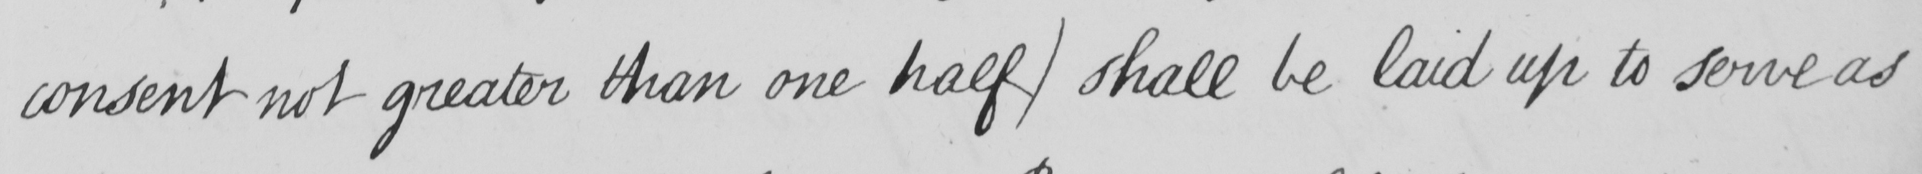Please provide the text content of this handwritten line. consent not greater than one half )  shall be laid up to serve as 